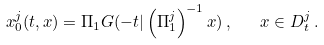<formula> <loc_0><loc_0><loc_500><loc_500>x _ { 0 } ^ { j } ( t , x ) = \Pi _ { 1 } G ( - t | \left ( \Pi _ { 1 } ^ { j } \right ) ^ { - 1 } x ) \, , \quad x \in D _ { t } ^ { j } \, .</formula> 